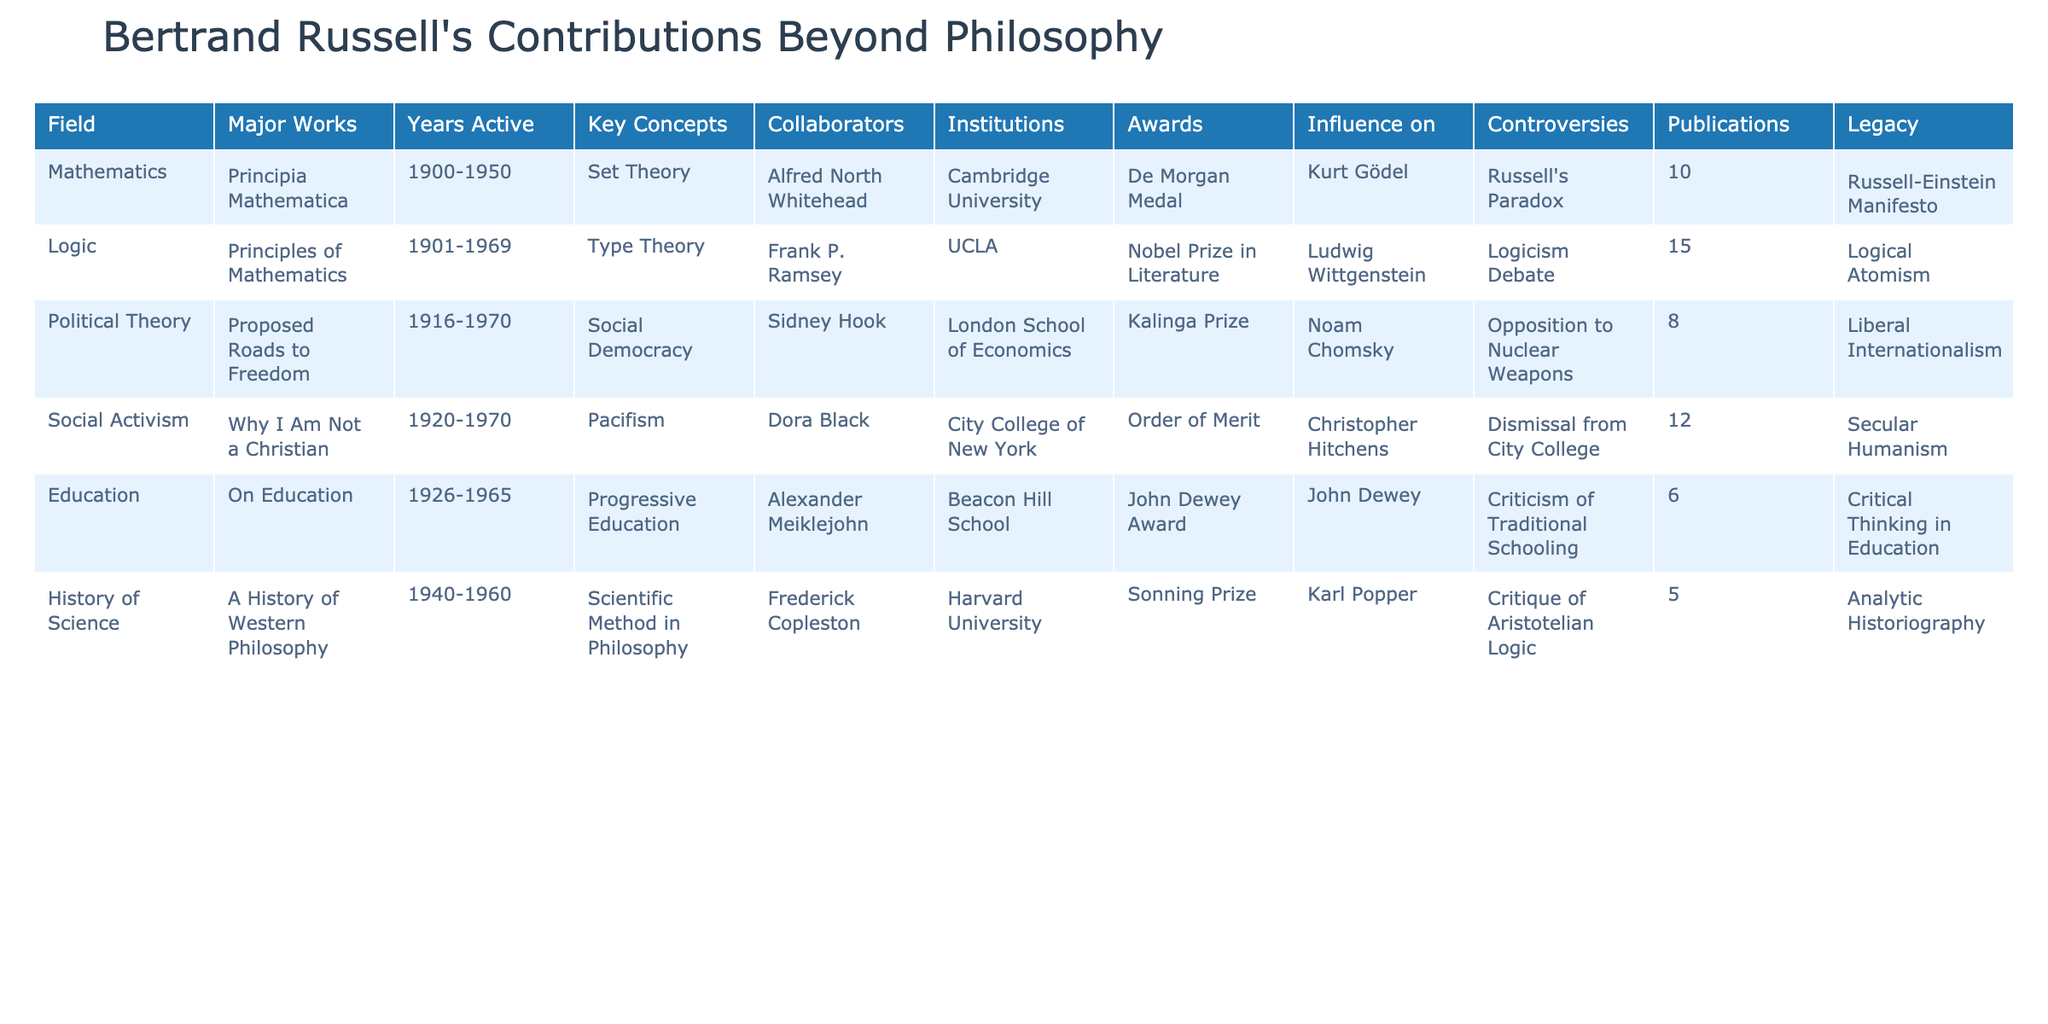What is one of Bertrand Russell's major works in the field of Mathematics? According to the table, one of Russell's major works in Mathematics is "Principia Mathematica."
Answer: "Principia Mathematica" Who are Russell's collaborators in the field of Logic? The table lists Frank P. Ramsey as a collaborator in the field of Logic.
Answer: Frank P. Ramsey How many publications did Russell have in the field of Political Theory? The table shows that Russell had 8 publications in Political Theory.
Answer: 8 Which award did Bertrand Russell receive for his contributions to Political Theory? The table indicates that Russell received the Kalinga Prize for his work in Political Theory.
Answer: Kalinga Prize Is it true that Bertrand Russell was opposed to nuclear weapons? Yes, the table states that Russell had controversies related to his opposition to nuclear weapons.
Answer: Yes What is the difference in the number of publications between Mathematics and Education? The table shows Mathematics had 10 publications and Education had 6 publications. The difference is 10 - 6 = 4.
Answer: 4 Which field had the longest range of years active according to the table? Looking at the years active for each field listed, Mathematics spans from 1900 to 1950, which is 50 years. Logic follows with 1901 to 1969, also 68 years. Therefore, Logic had the longest duration active.
Answer: Logic What legacy concept is associated with Russell's work in Social Activism? The table shows that the legacy concept associated with Russell's work in Social Activism is "Secular Humanism."
Answer: Secular Humanism How many total years was Russell active across all fields combined? Russell's active years are given as follows: Mathematics (50 years), Logic (68 years), Political Theory (54 years), Social Activism (50 years), Education (39 years), and History of Science (20 years). Adding these gives 50 + 68 + 54 + 50 + 39 + 20 = 281 total years.
Answer: 281 List the influence of Russell in the field of Education. The table states that John Dewey was influenced by Russell in the field of Education.
Answer: John Dewey 